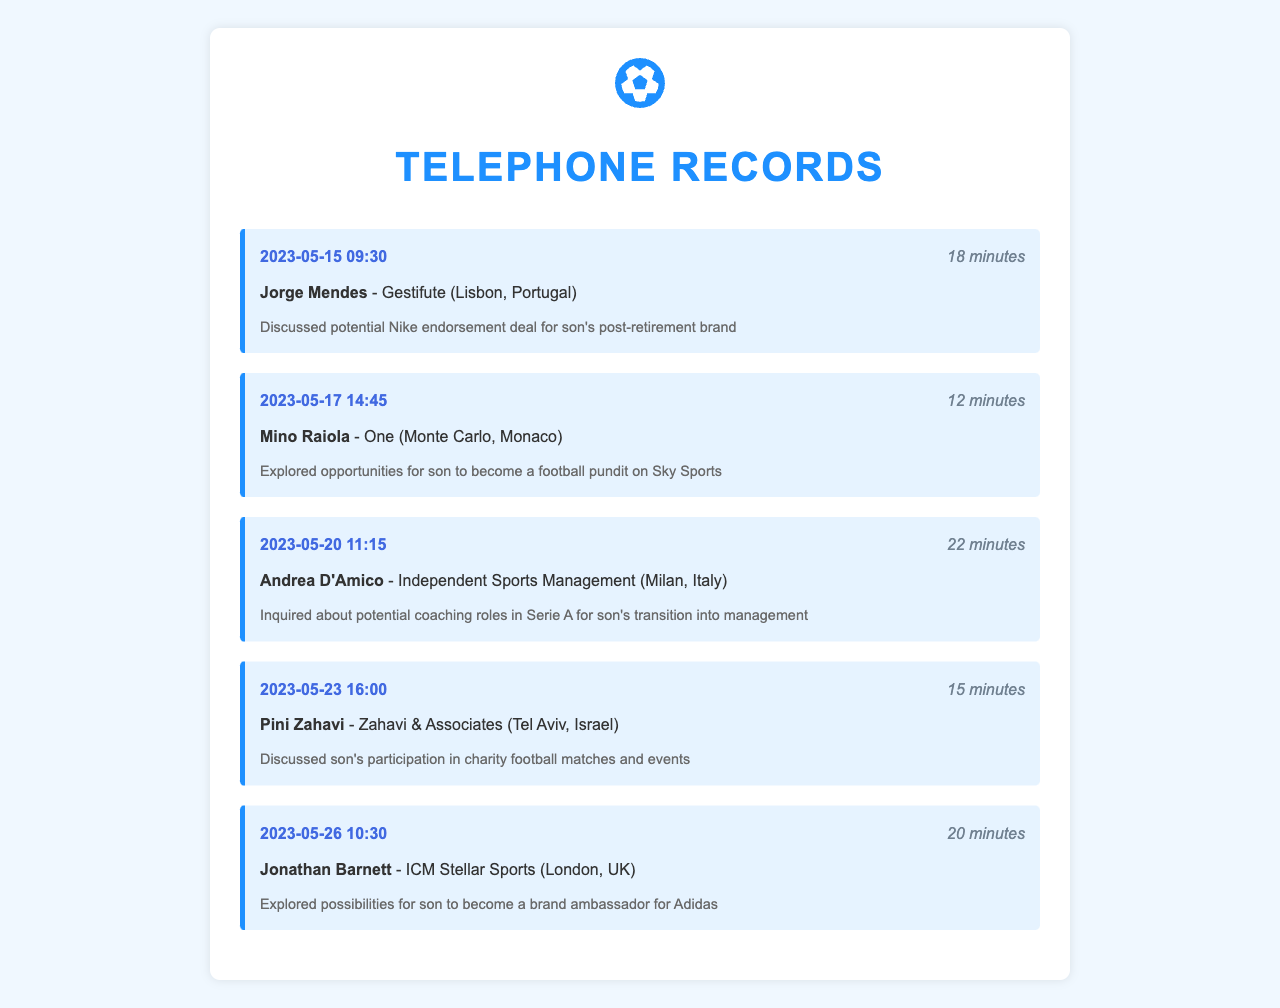what is the date of the call with Jorge Mendes? The date of the call with Jorge Mendes is stated in the first record, which is May 15, 2023.
Answer: May 15, 2023 how long was the call with Mino Raiola? The duration of the call with Mino Raiola is provided in the second record, which is 12 minutes.
Answer: 12 minutes who was discussed for the Adidas brand ambassador role? The document notes that potential opportunities for becoming a brand ambassador for Adidas were discussed for the retired player, specifically in the record with Jonathan Barnett.
Answer: son what topic was covered during the call with Andrea D'Amico? The call with Andrea D'Amico focused on potential coaching roles in Serie A for the son's transition into management, as noted in the record.
Answer: coaching roles in Serie A who is the contact person for discussing Nike endorsement deals? The contact person mentioned for the Nike endorsement deal discussion is Jorge Mendes.
Answer: Jorge Mendes how many minutes was the call discussing charity matches? The duration of the call discussing charity football matches with Pini Zahavi is noted in the record as 15 minutes.
Answer: 15 minutes what company is Mino Raiola associated with? Mino Raiola is associated with the company One, as noted in the record where he is mentioned.
Answer: One what type of appearances are being discussed for the retired player? The document includes potential media appearances, specifically as a football pundit on Sky Sports, discussed during the call with Mino Raiola.
Answer: football pundit which city is Jonathan Barnett located in? The document specifies that Jonathan Barnett is located in London, UK, as mentioned in the record.
Answer: London, UK 